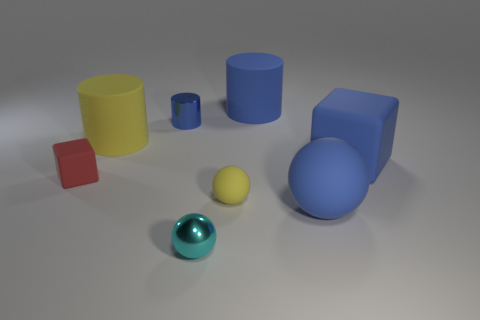Add 2 small purple objects. How many objects exist? 10 Subtract all big matte cylinders. How many cylinders are left? 1 Subtract all cylinders. How many objects are left? 5 Add 2 tiny yellow shiny balls. How many tiny yellow shiny balls exist? 2 Subtract 1 blue cylinders. How many objects are left? 7 Subtract all blue metallic things. Subtract all tiny brown shiny blocks. How many objects are left? 7 Add 4 large blue matte things. How many large blue matte things are left? 7 